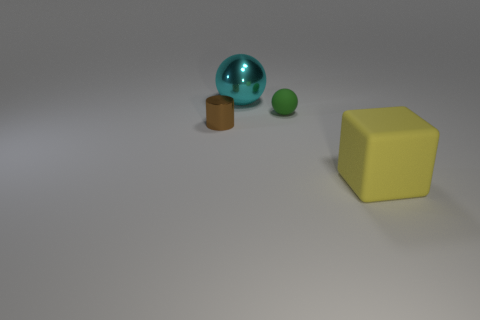Add 1 big cyan metal spheres. How many objects exist? 5 Subtract all blocks. How many objects are left? 3 Subtract 1 yellow blocks. How many objects are left? 3 Subtract all green cylinders. Subtract all balls. How many objects are left? 2 Add 3 big metallic objects. How many big metallic objects are left? 4 Add 2 big red cubes. How many big red cubes exist? 2 